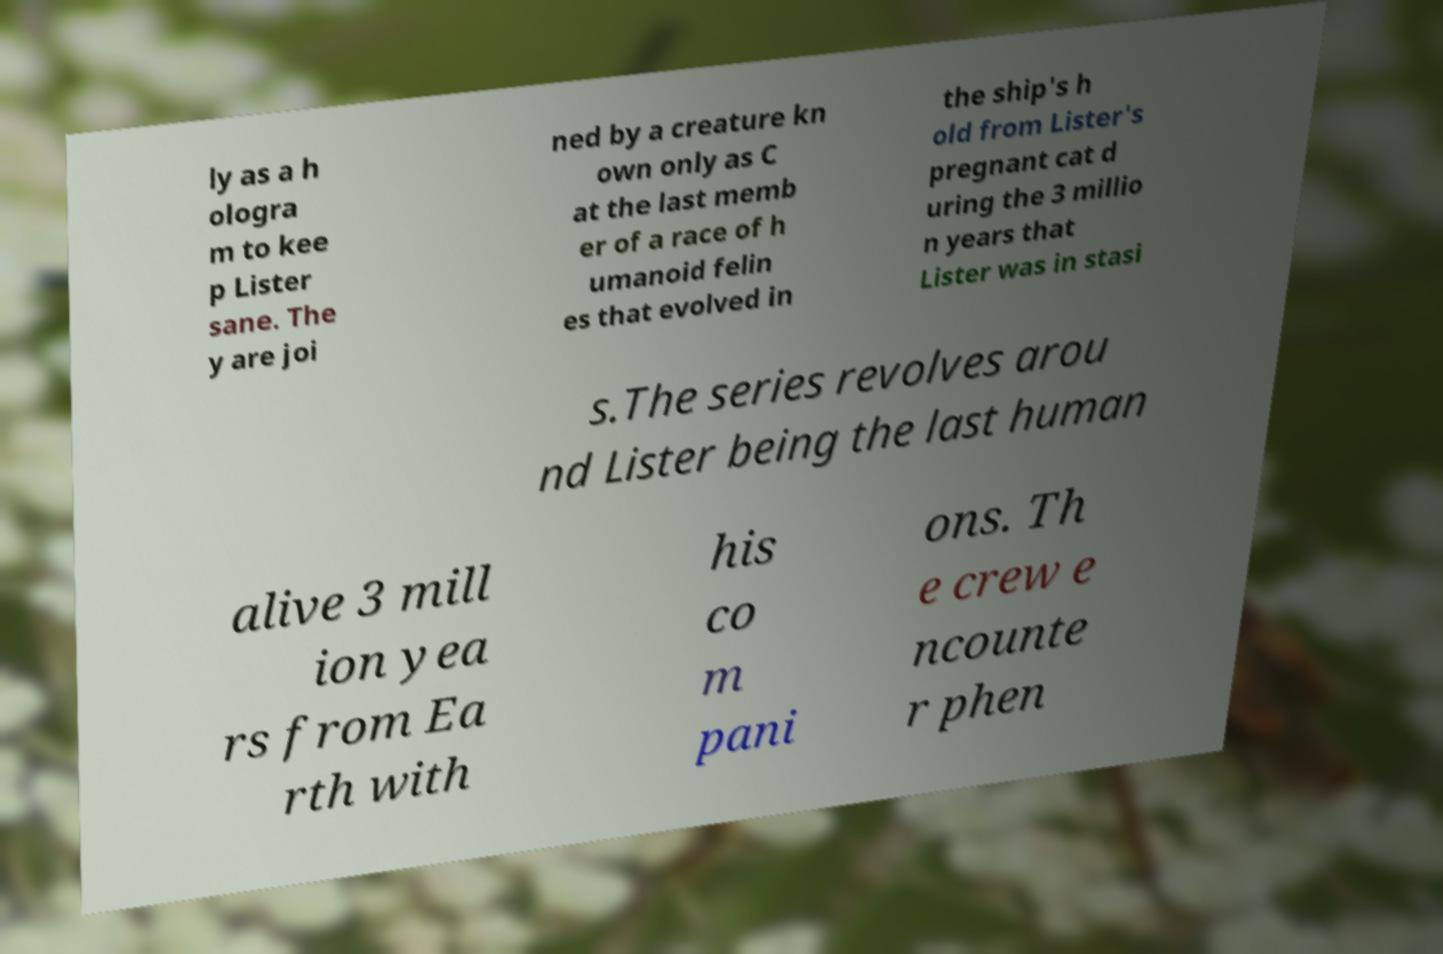Can you read and provide the text displayed in the image?This photo seems to have some interesting text. Can you extract and type it out for me? ly as a h ologra m to kee p Lister sane. The y are joi ned by a creature kn own only as C at the last memb er of a race of h umanoid felin es that evolved in the ship's h old from Lister's pregnant cat d uring the 3 millio n years that Lister was in stasi s.The series revolves arou nd Lister being the last human alive 3 mill ion yea rs from Ea rth with his co m pani ons. Th e crew e ncounte r phen 